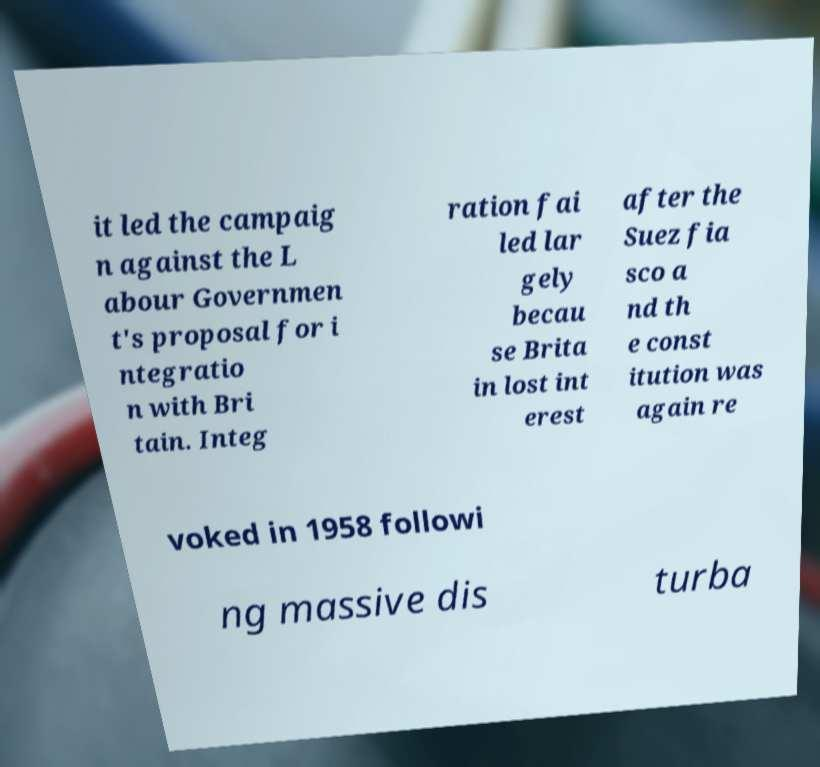Can you read and provide the text displayed in the image?This photo seems to have some interesting text. Can you extract and type it out for me? it led the campaig n against the L abour Governmen t's proposal for i ntegratio n with Bri tain. Integ ration fai led lar gely becau se Brita in lost int erest after the Suez fia sco a nd th e const itution was again re voked in 1958 followi ng massive dis turba 